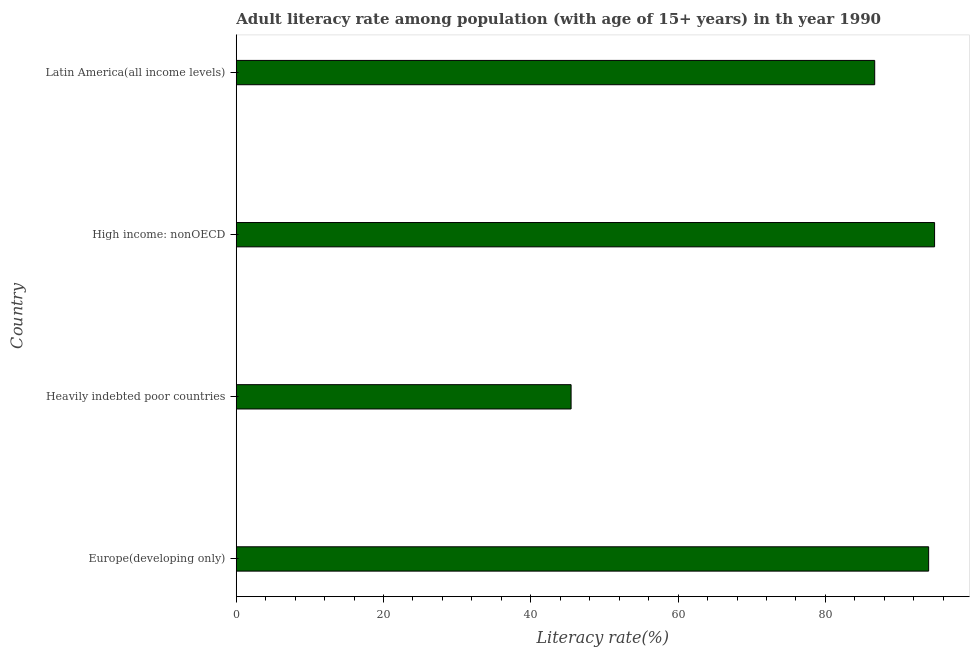What is the title of the graph?
Provide a short and direct response. Adult literacy rate among population (with age of 15+ years) in th year 1990. What is the label or title of the X-axis?
Offer a terse response. Literacy rate(%). What is the label or title of the Y-axis?
Offer a terse response. Country. What is the adult literacy rate in Latin America(all income levels)?
Give a very brief answer. 86.7. Across all countries, what is the maximum adult literacy rate?
Offer a terse response. 94.83. Across all countries, what is the minimum adult literacy rate?
Keep it short and to the point. 45.47. In which country was the adult literacy rate maximum?
Make the answer very short. High income: nonOECD. In which country was the adult literacy rate minimum?
Your answer should be very brief. Heavily indebted poor countries. What is the sum of the adult literacy rate?
Make the answer very short. 321.03. What is the difference between the adult literacy rate in Europe(developing only) and High income: nonOECD?
Ensure brevity in your answer.  -0.81. What is the average adult literacy rate per country?
Provide a short and direct response. 80.26. What is the median adult literacy rate?
Offer a very short reply. 90.36. What is the ratio of the adult literacy rate in Europe(developing only) to that in Heavily indebted poor countries?
Ensure brevity in your answer.  2.07. What is the difference between the highest and the second highest adult literacy rate?
Offer a terse response. 0.81. Is the sum of the adult literacy rate in Europe(developing only) and Heavily indebted poor countries greater than the maximum adult literacy rate across all countries?
Provide a short and direct response. Yes. What is the difference between the highest and the lowest adult literacy rate?
Give a very brief answer. 49.36. Are all the bars in the graph horizontal?
Provide a short and direct response. Yes. How many countries are there in the graph?
Ensure brevity in your answer.  4. Are the values on the major ticks of X-axis written in scientific E-notation?
Provide a succinct answer. No. What is the Literacy rate(%) of Europe(developing only)?
Provide a short and direct response. 94.03. What is the Literacy rate(%) in Heavily indebted poor countries?
Provide a succinct answer. 45.47. What is the Literacy rate(%) of High income: nonOECD?
Make the answer very short. 94.83. What is the Literacy rate(%) in Latin America(all income levels)?
Make the answer very short. 86.7. What is the difference between the Literacy rate(%) in Europe(developing only) and Heavily indebted poor countries?
Keep it short and to the point. 48.56. What is the difference between the Literacy rate(%) in Europe(developing only) and High income: nonOECD?
Offer a very short reply. -0.81. What is the difference between the Literacy rate(%) in Europe(developing only) and Latin America(all income levels)?
Keep it short and to the point. 7.32. What is the difference between the Literacy rate(%) in Heavily indebted poor countries and High income: nonOECD?
Offer a terse response. -49.36. What is the difference between the Literacy rate(%) in Heavily indebted poor countries and Latin America(all income levels)?
Make the answer very short. -41.23. What is the difference between the Literacy rate(%) in High income: nonOECD and Latin America(all income levels)?
Make the answer very short. 8.13. What is the ratio of the Literacy rate(%) in Europe(developing only) to that in Heavily indebted poor countries?
Your answer should be compact. 2.07. What is the ratio of the Literacy rate(%) in Europe(developing only) to that in Latin America(all income levels)?
Make the answer very short. 1.08. What is the ratio of the Literacy rate(%) in Heavily indebted poor countries to that in High income: nonOECD?
Offer a terse response. 0.48. What is the ratio of the Literacy rate(%) in Heavily indebted poor countries to that in Latin America(all income levels)?
Give a very brief answer. 0.52. What is the ratio of the Literacy rate(%) in High income: nonOECD to that in Latin America(all income levels)?
Your answer should be very brief. 1.09. 